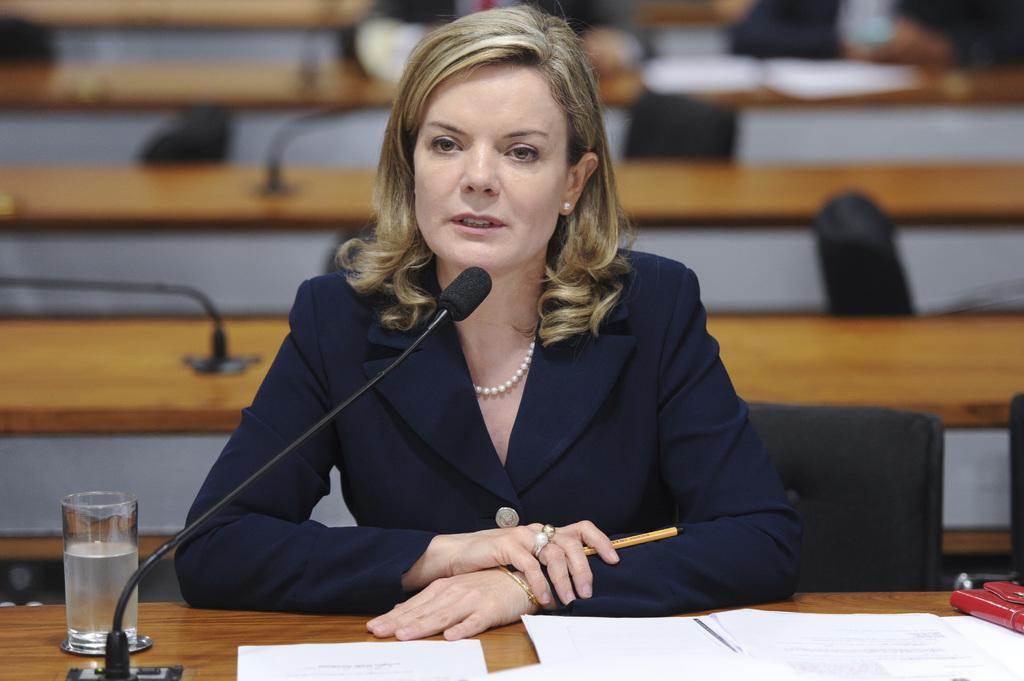Who is present in the image? There is a woman in the image. What is in front of the woman? There is a table in front of the woman. What objects are on the table? There is a microphone, papers, and a glass of water on the table. Can you describe the background of the image? The background of the image is blurred, but tables and chairs are visible. What type of quicksand can be seen in the background of the image? There is no quicksand present in the image; the background features tables and chairs. 